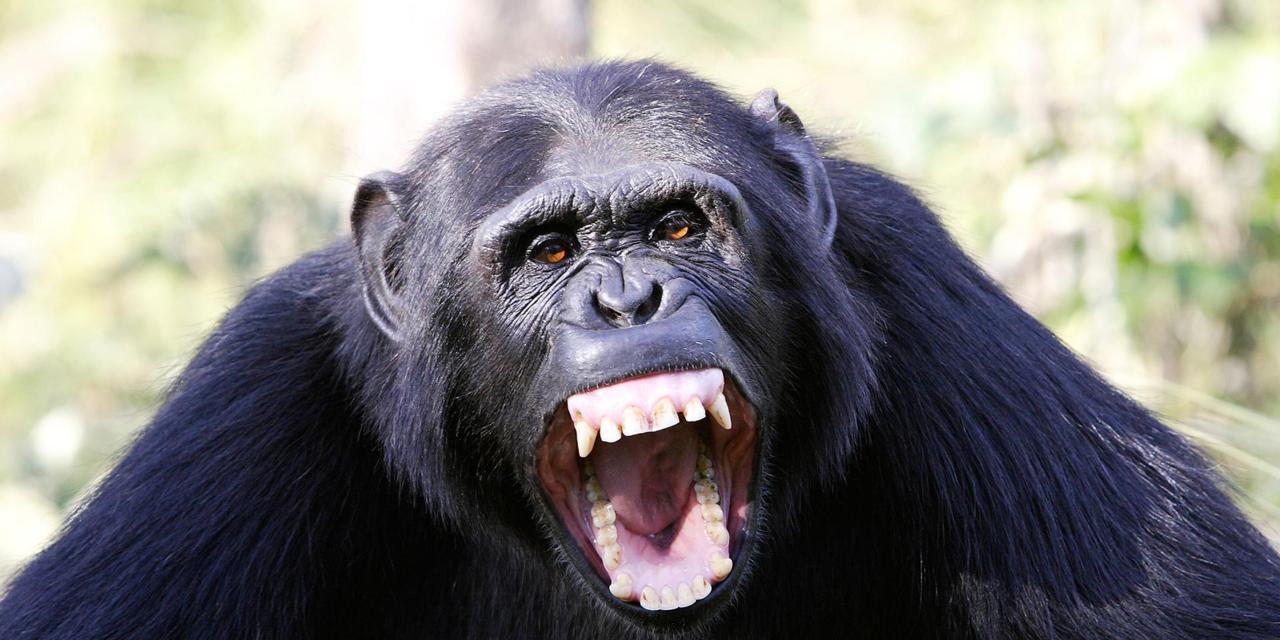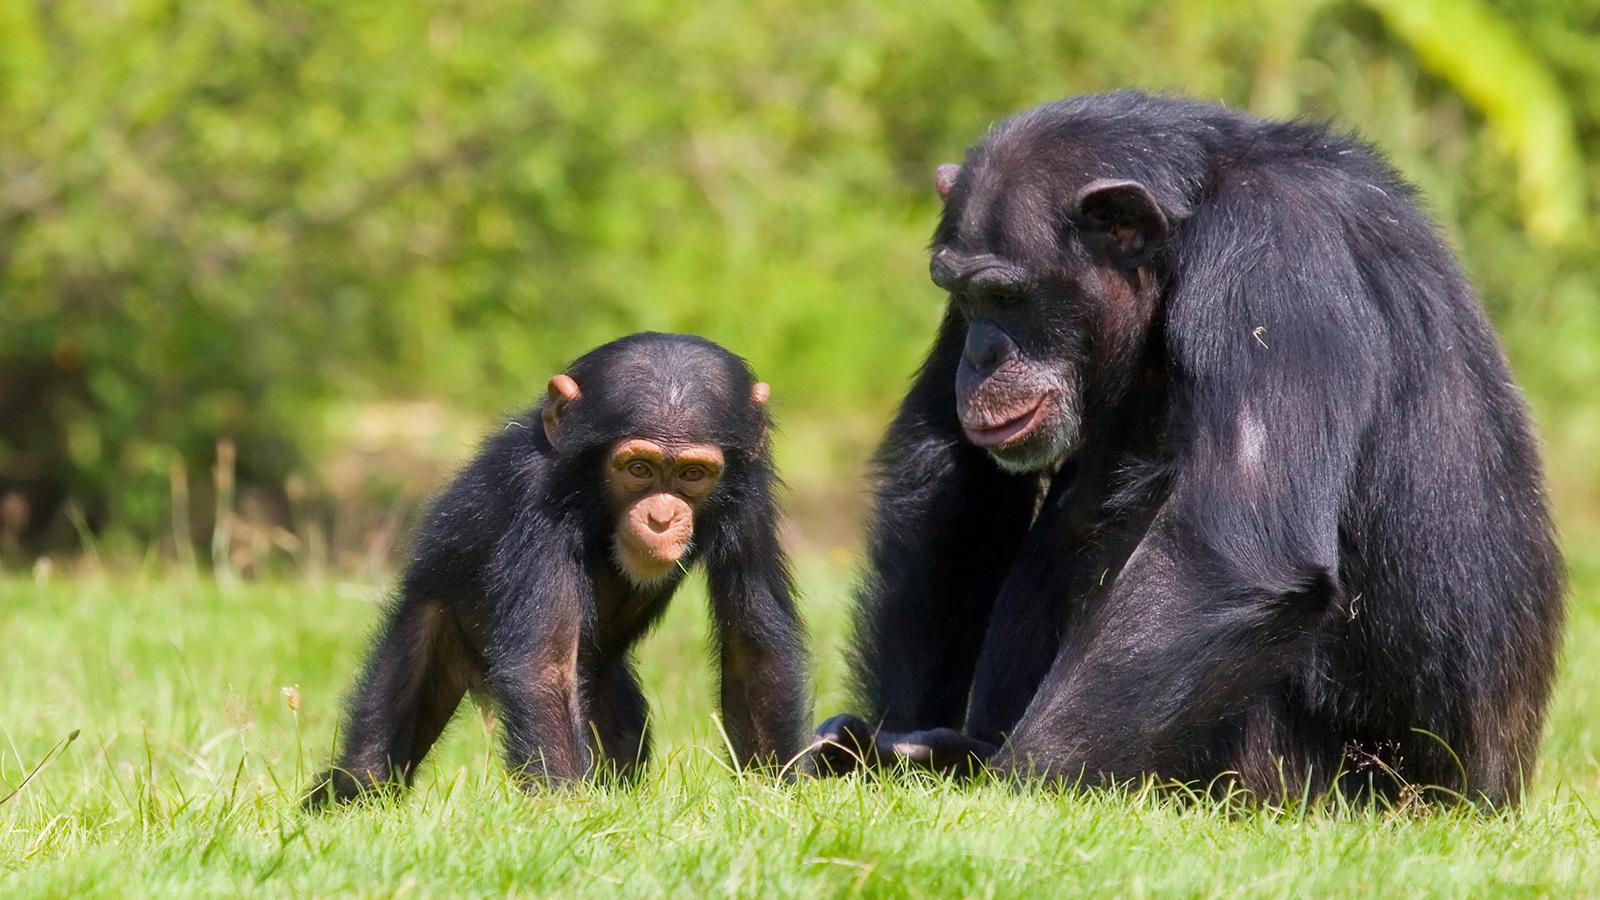The first image is the image on the left, the second image is the image on the right. Analyze the images presented: Is the assertion "At least one of the images shows more than one chimpanzee." valid? Answer yes or no. Yes. 